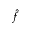Convert formula to latex. <formula><loc_0><loc_0><loc_500><loc_500>\hat { f }</formula> 